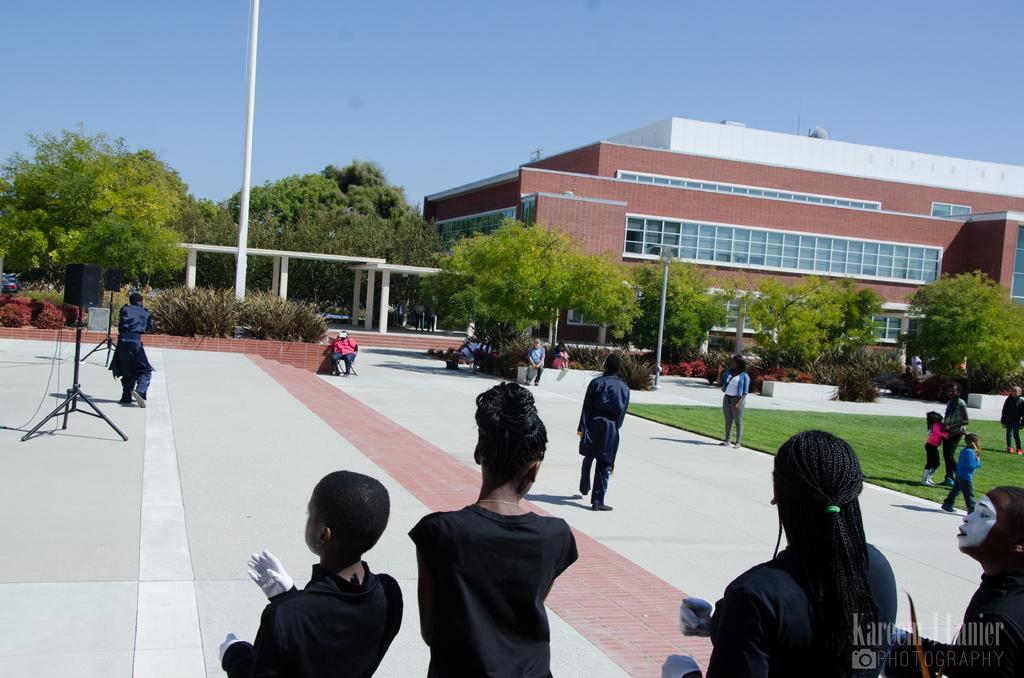What is located at the bottom of the image? There are persons standing on the ground and floor at the bottom of the image. What can be seen at the top of the image? There is a building and trees visible at the top of the image. What is visible in the background of the image? The sky is visible at the top of the image. What type of fruit can be seen being crushed in the image? There is no fruit being crushed in the image; it features persons standing on the ground and floor, a building, trees, and the sky. What type of machine is used to stretch the trees in the image? There is no machine or stretching of trees present in the image; it only shows trees in the background. 